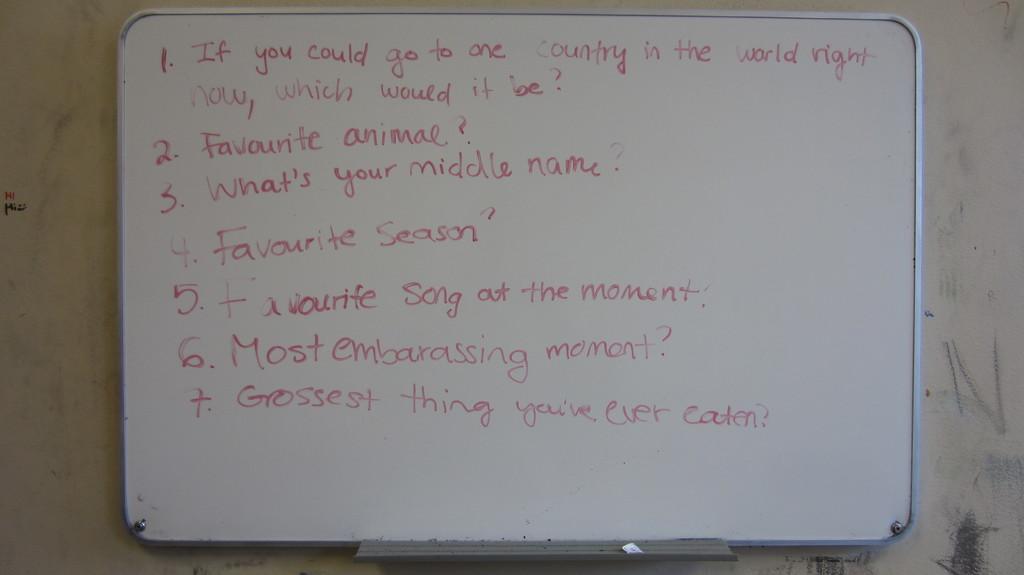What's question number 3?
Offer a terse response. What's your middle name?. What is listed as number 4?
Make the answer very short. Favorite season. 